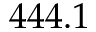Convert formula to latex. <formula><loc_0><loc_0><loc_500><loc_500>4 4 4 . 1</formula> 